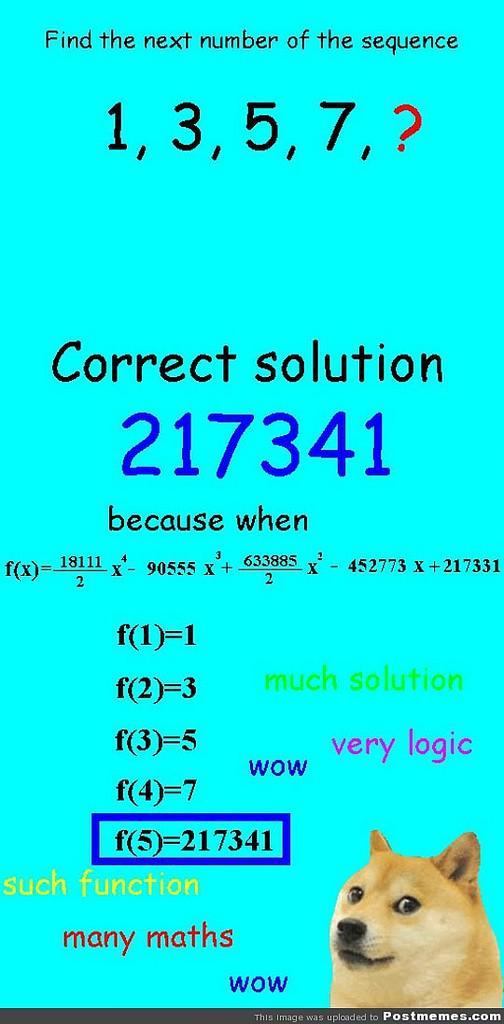What type of animal is in the image? There is a dog in the image. Can you describe the dog's coloring? The dog has cream, brown, and black coloring. What else is present in the image besides the dog? There is text written on a blue background in the image. What colors are used for the text? The text uses black, blue, and green colors. What type of coach is the dog driving in the image? There is no coach present in the image; it features a dog with a specific coloring and text on a blue background. 